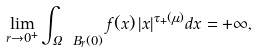<formula> <loc_0><loc_0><loc_500><loc_500>\lim _ { r \to 0 ^ { + } } \int _ { \Omega \ B _ { r } ( 0 ) } f ( x ) \, | x | ^ { \tau _ { + } ( \mu ) } d x = + \infty ,</formula> 